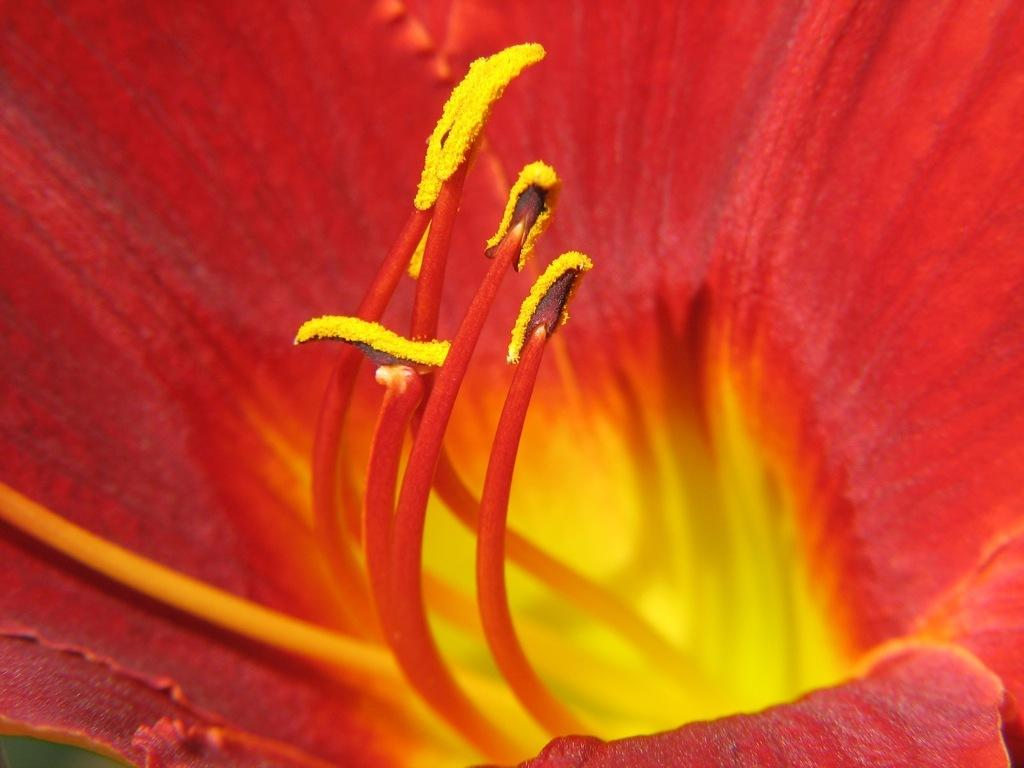What type of flower is present in the image? The image contains a red flower. What can be observed in the center of the flower? The flower has yellow anthers in the center. What color are the petals of the flower? The flower has red petals. What type of toothpaste is being used to treat the anger in the image? There is no toothpaste or anger present in the image; it features a red flower with yellow anthers and red petals. 